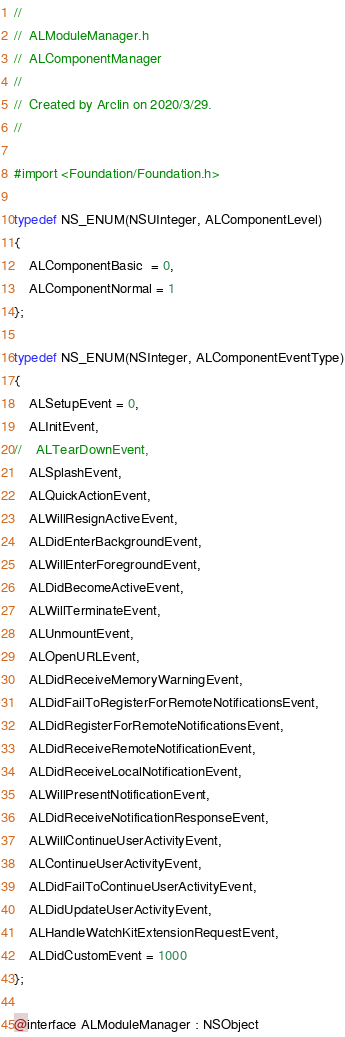<code> <loc_0><loc_0><loc_500><loc_500><_C_>//
//  ALModuleManager.h
//  ALComponentManager
//
//  Created by Arclin on 2020/3/29.
//

#import <Foundation/Foundation.h>

typedef NS_ENUM(NSUInteger, ALComponentLevel)
{
    ALComponentBasic  = 0,
    ALComponentNormal = 1
};

typedef NS_ENUM(NSInteger, ALComponentEventType)
{
    ALSetupEvent = 0,
    ALInitEvent,
//    ALTearDownEvent,
    ALSplashEvent,
    ALQuickActionEvent,
    ALWillResignActiveEvent,
    ALDidEnterBackgroundEvent,
    ALWillEnterForegroundEvent,
    ALDidBecomeActiveEvent,
    ALWillTerminateEvent,
    ALUnmountEvent,
    ALOpenURLEvent,
    ALDidReceiveMemoryWarningEvent,
    ALDidFailToRegisterForRemoteNotificationsEvent,
    ALDidRegisterForRemoteNotificationsEvent,
    ALDidReceiveRemoteNotificationEvent,
    ALDidReceiveLocalNotificationEvent,
    ALWillPresentNotificationEvent,
    ALDidReceiveNotificationResponseEvent,
    ALWillContinueUserActivityEvent,
    ALContinueUserActivityEvent,
    ALDidFailToContinueUserActivityEvent,
    ALDidUpdateUserActivityEvent,
    ALHandleWatchKitExtensionRequestEvent,
    ALDidCustomEvent = 1000
};

@interface ALModuleManager : NSObject
</code> 